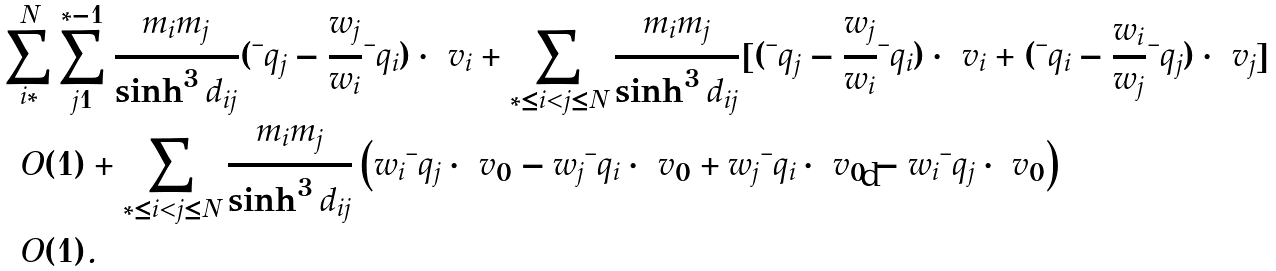Convert formula to latex. <formula><loc_0><loc_0><loc_500><loc_500>& \sum _ { i = * } ^ { N } \sum _ { j = 1 } ^ { * - 1 } \frac { m _ { i } m _ { j } } { \sinh ^ { 3 } d _ { i j } } ( \bar { \ } q _ { j } - \frac { w _ { j } } { w _ { i } } \bar { \ } q _ { i } ) \cdot \ v _ { i } + \sum _ { * \leq i < j \leq N } \frac { m _ { i } m _ { j } } { \sinh ^ { 3 } d _ { i j } } [ ( \bar { \ } q _ { j } - \frac { w _ { j } } { w _ { i } } \bar { \ } q _ { i } ) \cdot \ v _ { i } + ( \bar { \ } q _ { i } - \frac { w _ { i } } { w _ { j } } \bar { \ } q _ { j } ) \cdot \ v _ { j } ] \\ & = O ( 1 ) + \sum _ { * \leq i < j \leq N } \frac { m _ { i } m _ { j } } { \sinh ^ { 3 } d _ { i j } } \left ( w _ { i } \bar { \ } q _ { j } \cdot \ v _ { 0 } - w _ { j } \bar { \ } q _ { i } \cdot \ v _ { 0 } + w _ { j } \bar { \ } q _ { i } \cdot \ v _ { 0 } - w _ { i } \bar { \ } q _ { j } \cdot \ v _ { 0 } \right ) \\ & = O ( 1 ) .</formula> 